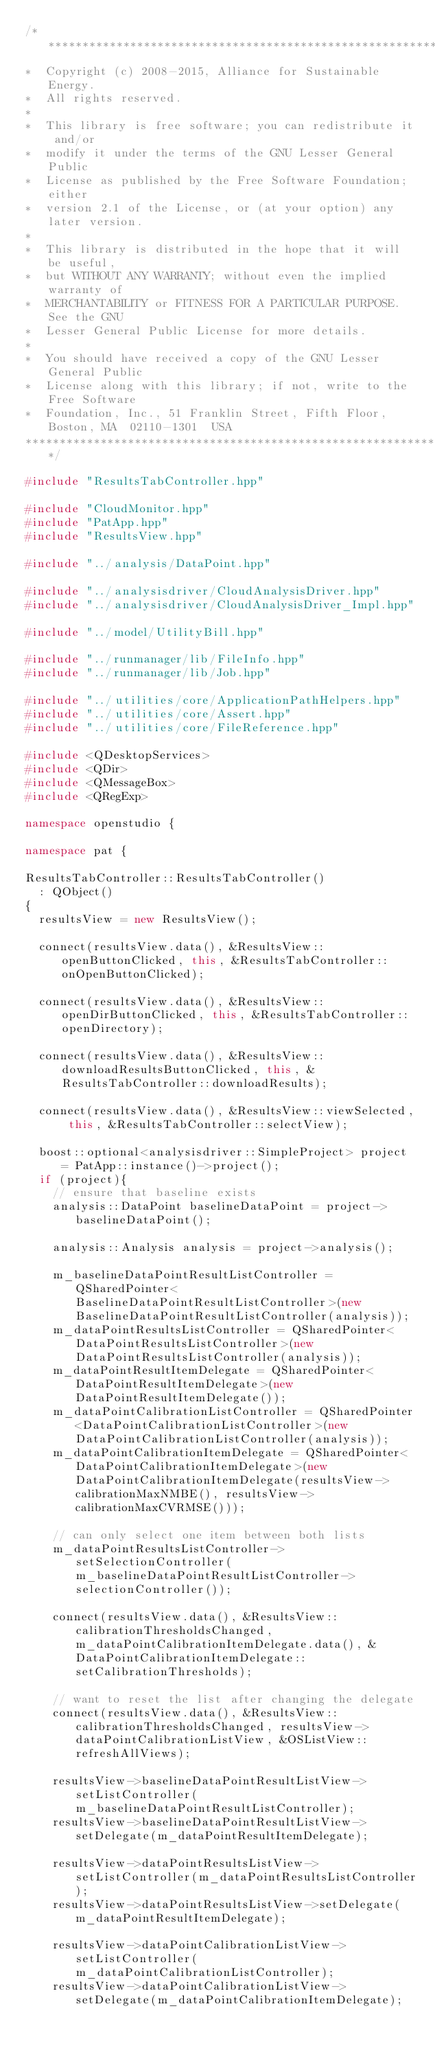Convert code to text. <code><loc_0><loc_0><loc_500><loc_500><_C++_>/**********************************************************************
*  Copyright (c) 2008-2015, Alliance for Sustainable Energy.
*  All rights reserved.
*
*  This library is free software; you can redistribute it and/or
*  modify it under the terms of the GNU Lesser General Public
*  License as published by the Free Software Foundation; either
*  version 2.1 of the License, or (at your option) any later version.
*
*  This library is distributed in the hope that it will be useful,
*  but WITHOUT ANY WARRANTY; without even the implied warranty of
*  MERCHANTABILITY or FITNESS FOR A PARTICULAR PURPOSE.  See the GNU
*  Lesser General Public License for more details.
*
*  You should have received a copy of the GNU Lesser General Public
*  License along with this library; if not, write to the Free Software
*  Foundation, Inc., 51 Franklin Street, Fifth Floor, Boston, MA  02110-1301  USA
**********************************************************************/

#include "ResultsTabController.hpp"

#include "CloudMonitor.hpp"
#include "PatApp.hpp"
#include "ResultsView.hpp"

#include "../analysis/DataPoint.hpp"

#include "../analysisdriver/CloudAnalysisDriver.hpp"
#include "../analysisdriver/CloudAnalysisDriver_Impl.hpp"

#include "../model/UtilityBill.hpp"

#include "../runmanager/lib/FileInfo.hpp"
#include "../runmanager/lib/Job.hpp"

#include "../utilities/core/ApplicationPathHelpers.hpp"
#include "../utilities/core/Assert.hpp"
#include "../utilities/core/FileReference.hpp"

#include <QDesktopServices>
#include <QDir>
#include <QMessageBox>
#include <QRegExp>

namespace openstudio {

namespace pat {

ResultsTabController::ResultsTabController()
  : QObject()
{
  resultsView = new ResultsView();

  connect(resultsView.data(), &ResultsView::openButtonClicked, this, &ResultsTabController::onOpenButtonClicked);

  connect(resultsView.data(), &ResultsView::openDirButtonClicked, this, &ResultsTabController::openDirectory);
  
  connect(resultsView.data(), &ResultsView::downloadResultsButtonClicked, this, &ResultsTabController::downloadResults);

  connect(resultsView.data(), &ResultsView::viewSelected, this, &ResultsTabController::selectView);

  boost::optional<analysisdriver::SimpleProject> project = PatApp::instance()->project();
  if (project){
    // ensure that baseline exists
    analysis::DataPoint baselineDataPoint = project->baselineDataPoint();

    analysis::Analysis analysis = project->analysis();

    m_baselineDataPointResultListController = QSharedPointer<BaselineDataPointResultListController>(new BaselineDataPointResultListController(analysis));
    m_dataPointResultsListController = QSharedPointer<DataPointResultsListController>(new DataPointResultsListController(analysis));
    m_dataPointResultItemDelegate = QSharedPointer<DataPointResultItemDelegate>(new DataPointResultItemDelegate());
    m_dataPointCalibrationListController = QSharedPointer<DataPointCalibrationListController>(new DataPointCalibrationListController(analysis));
    m_dataPointCalibrationItemDelegate = QSharedPointer<DataPointCalibrationItemDelegate>(new DataPointCalibrationItemDelegate(resultsView->calibrationMaxNMBE(), resultsView->calibrationMaxCVRMSE()));

    // can only select one item between both lists
    m_dataPointResultsListController->setSelectionController(m_baselineDataPointResultListController->selectionController());

    connect(resultsView.data(), &ResultsView::calibrationThresholdsChanged, m_dataPointCalibrationItemDelegate.data(), &DataPointCalibrationItemDelegate::setCalibrationThresholds);

    // want to reset the list after changing the delegate
    connect(resultsView.data(), &ResultsView::calibrationThresholdsChanged, resultsView->dataPointCalibrationListView, &OSListView::refreshAllViews);

    resultsView->baselineDataPointResultListView->setListController(m_baselineDataPointResultListController);
    resultsView->baselineDataPointResultListView->setDelegate(m_dataPointResultItemDelegate);

    resultsView->dataPointResultsListView->setListController(m_dataPointResultsListController);
    resultsView->dataPointResultsListView->setDelegate(m_dataPointResultItemDelegate);

    resultsView->dataPointCalibrationListView->setListController(m_dataPointCalibrationListController);
    resultsView->dataPointCalibrationListView->setDelegate(m_dataPointCalibrationItemDelegate);
   </code> 